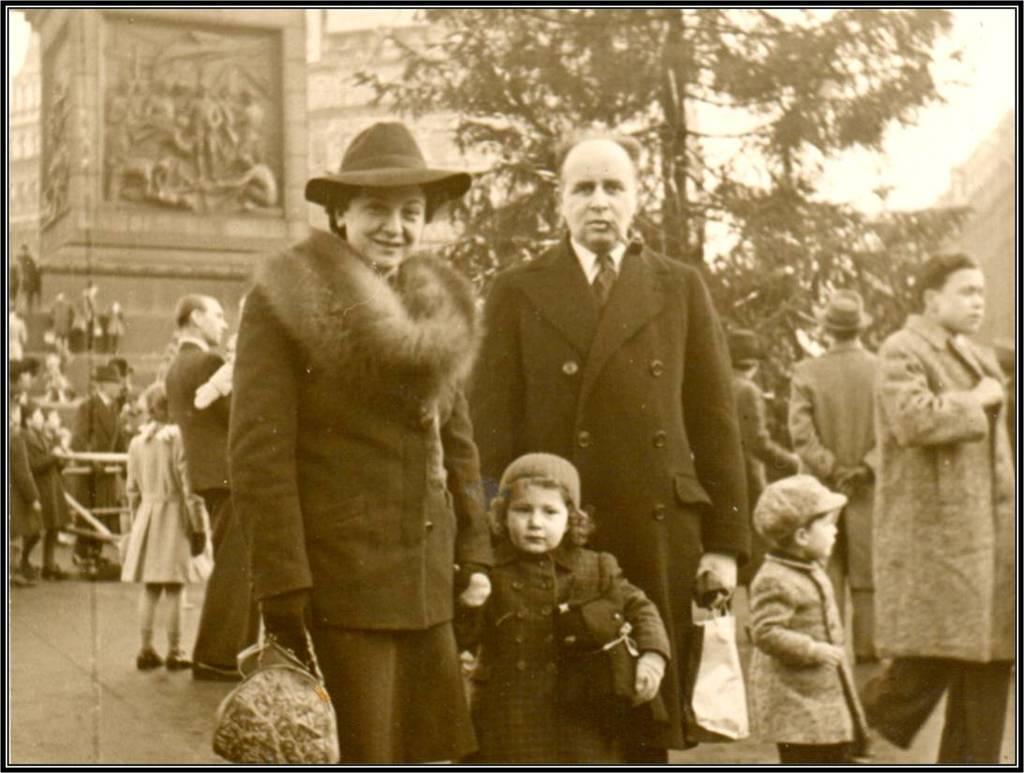Can you describe this image briefly? In this image I can see the group of people with the dresses. I can see few people with the hats and one person is holding the bag. In the background there are trees, building and the sky. 